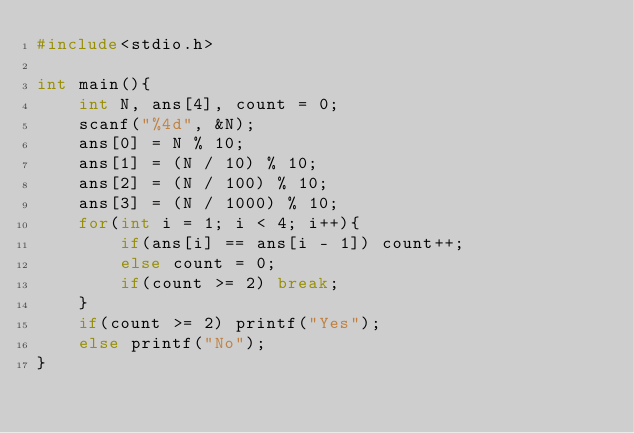<code> <loc_0><loc_0><loc_500><loc_500><_C_>#include<stdio.h>

int main(){
    int N, ans[4], count = 0;
    scanf("%4d", &N);
    ans[0] = N % 10;
    ans[1] = (N / 10) % 10;
    ans[2] = (N / 100) % 10;
    ans[3] = (N / 1000) % 10;
    for(int i = 1; i < 4; i++){
        if(ans[i] == ans[i - 1]) count++;
        else count = 0;
        if(count >= 2) break;
    }
    if(count >= 2) printf("Yes");
    else printf("No");
}</code> 